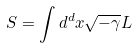<formula> <loc_0><loc_0><loc_500><loc_500>S = \int d ^ { d } x \sqrt { - \gamma } L</formula> 